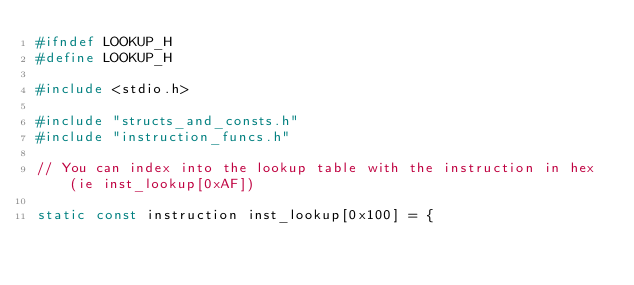Convert code to text. <code><loc_0><loc_0><loc_500><loc_500><_C_>#ifndef LOOKUP_H
#define LOOKUP_H

#include <stdio.h>

#include "structs_and_consts.h"
#include "instruction_funcs.h"

// You can index into the lookup table with the instruction in hex (ie inst_lookup[0xAF])

static const instruction inst_lookup[0x100] = {</code> 